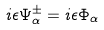Convert formula to latex. <formula><loc_0><loc_0><loc_500><loc_500>i \epsilon \Psi _ { \alpha } ^ { \pm } = i \epsilon \Phi _ { \alpha }</formula> 